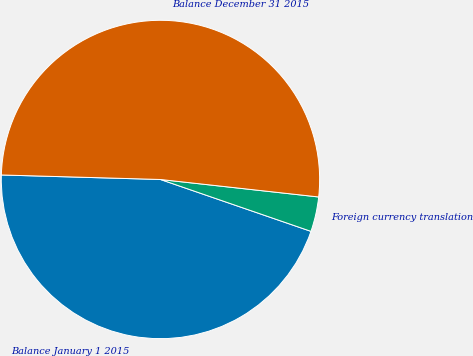Convert chart to OTSL. <chart><loc_0><loc_0><loc_500><loc_500><pie_chart><fcel>Balance January 1 2015<fcel>Foreign currency translation<fcel>Balance December 31 2015<nl><fcel>45.17%<fcel>3.53%<fcel>51.3%<nl></chart> 